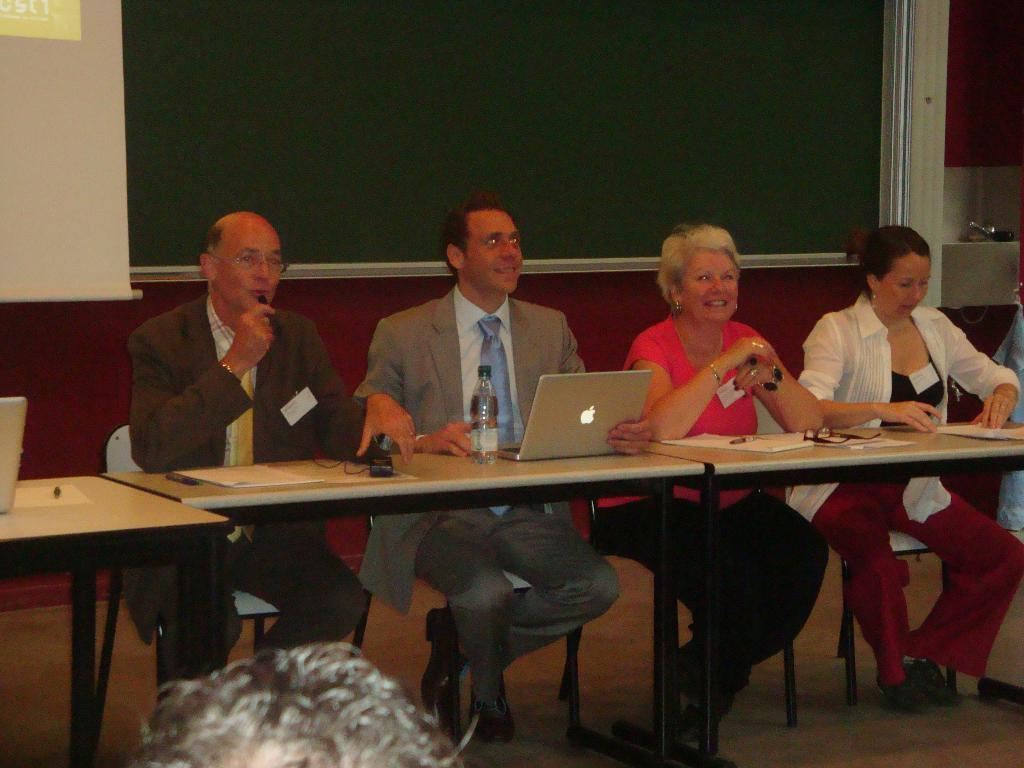How many people are sitting near the table in the image? There are four people sitting on chairs near a table in the image. What objects can be seen on the table? There is a water bottle, a laptop, spectacles, and papers on the table. What might the people be using the laptop for? The people might be using the laptop for work, browsing the internet, or other activities. What could be used for vision correction on the table? There are spectacles on the table that could be used for vision correction. How does the table measure the nerve of the people in the image? The table does not measure the nerve of the people in the image; it is an inanimate object and cannot perform such a task. 